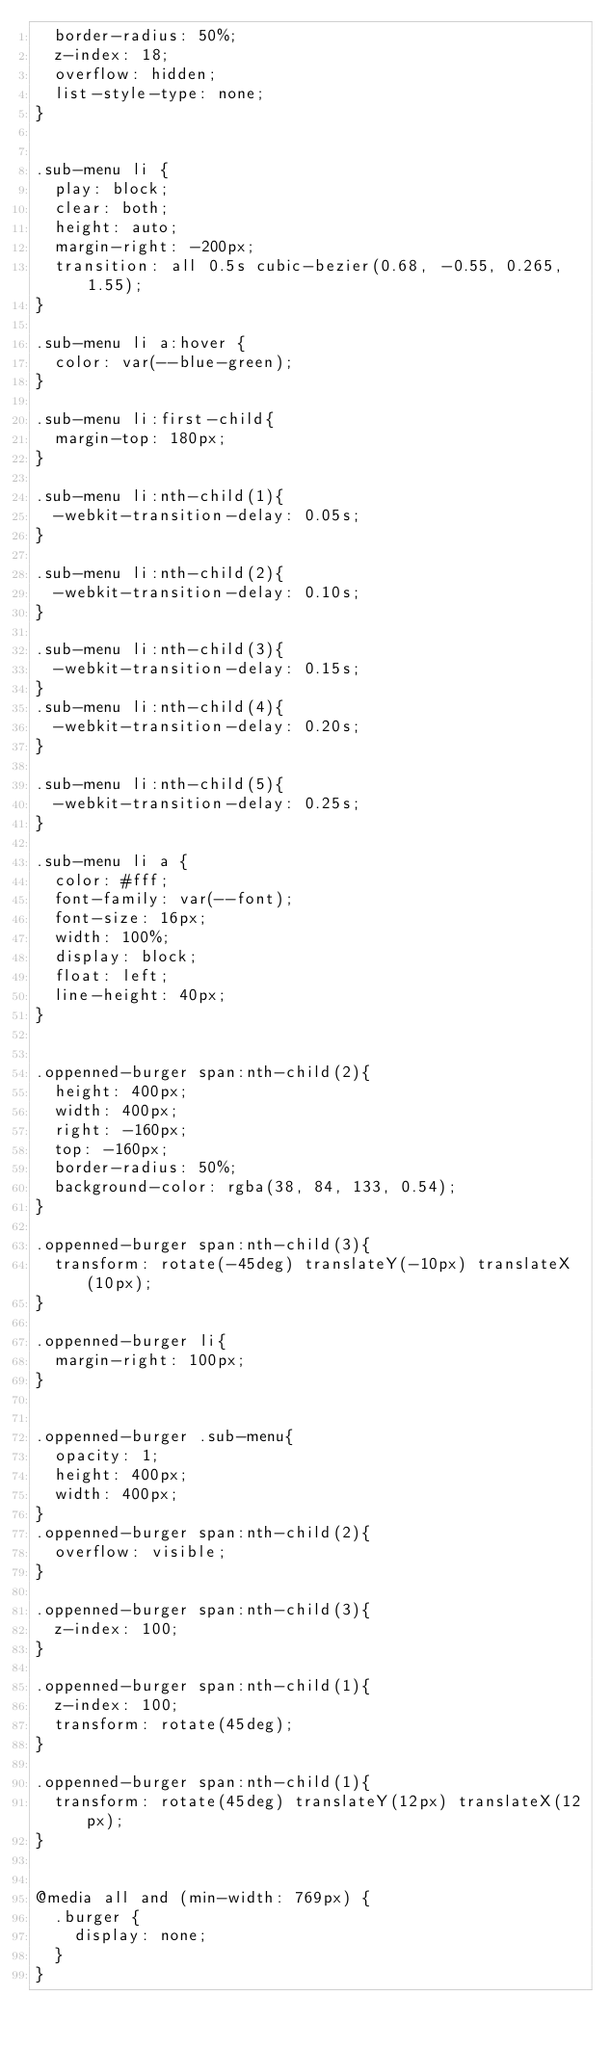<code> <loc_0><loc_0><loc_500><loc_500><_CSS_>	border-radius: 50%;
	z-index: 18;
	overflow: hidden;
	list-style-type: none;
}


.sub-menu li {
	play: block;
	clear: both;
	height: auto;
	margin-right: -200px;
	transition: all 0.5s cubic-bezier(0.68, -0.55, 0.265, 1.55);
}

.sub-menu li a:hover {
	color: var(--blue-green);
}

.sub-menu li:first-child{
	margin-top: 180px;
}

.sub-menu li:nth-child(1){
	-webkit-transition-delay: 0.05s;
}

.sub-menu li:nth-child(2){
	-webkit-transition-delay: 0.10s;
}

.sub-menu li:nth-child(3){
	-webkit-transition-delay: 0.15s;
}
.sub-menu li:nth-child(4){
	-webkit-transition-delay: 0.20s;
}

.sub-menu li:nth-child(5){
	-webkit-transition-delay: 0.25s;
}

.sub-menu li a {
	color: #fff;
	font-family: var(--font);
	font-size: 16px;
	width: 100%;
	display: block;
	float: left;
	line-height: 40px;
}


.oppenned-burger span:nth-child(2){
	height: 400px;
	width: 400px;
	right: -160px;
	top: -160px;
	border-radius: 50%;
	background-color: rgba(38, 84, 133, 0.54);
}

.oppenned-burger span:nth-child(3){
	transform: rotate(-45deg) translateY(-10px) translateX(10px);
}

.oppenned-burger li{
	margin-right: 100px;
}


.oppenned-burger .sub-menu{
	opacity: 1;
	height: 400px;
	width: 400px;
}
.oppenned-burger span:nth-child(2){
	overflow: visible;
}

.oppenned-burger span:nth-child(3){
	z-index: 100;
}

.oppenned-burger span:nth-child(1){
	z-index: 100;
	transform: rotate(45deg);
}

.oppenned-burger span:nth-child(1){
	transform: rotate(45deg) translateY(12px) translateX(12px);
}


@media all and (min-width: 769px) {
	.burger {
		display: none;
	}
}
</code> 